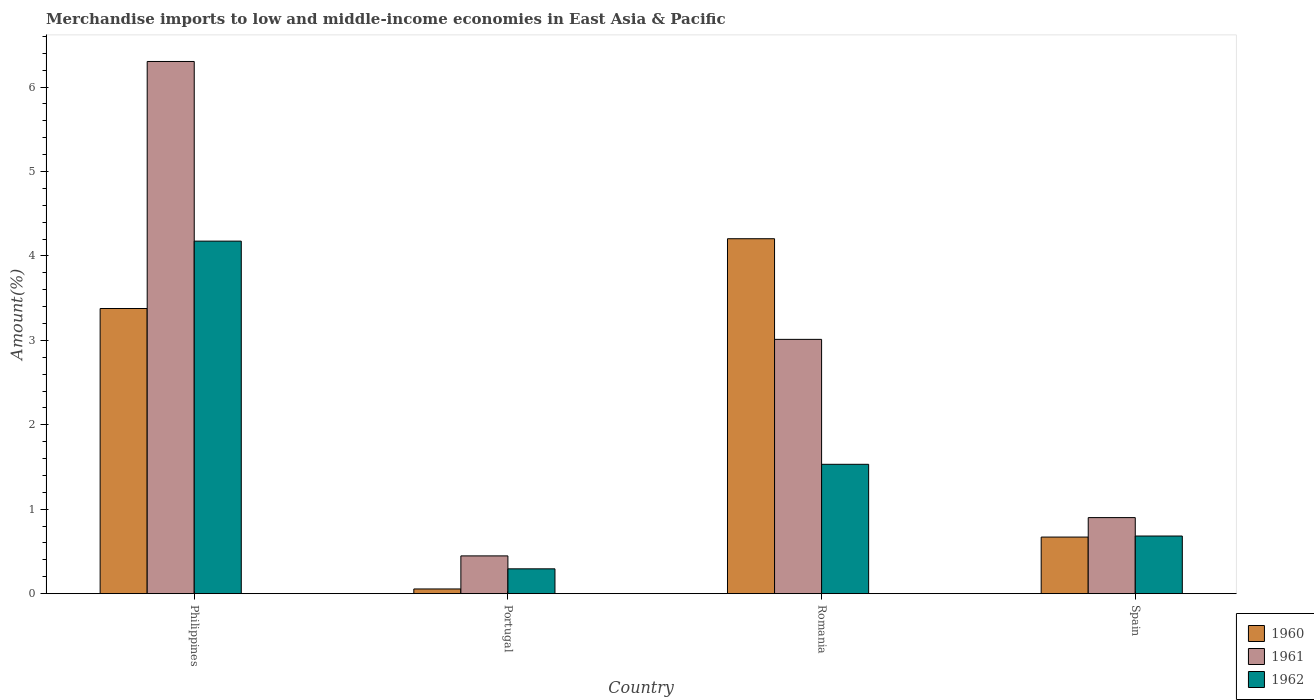How many groups of bars are there?
Give a very brief answer. 4. What is the percentage of amount earned from merchandise imports in 1962 in Portugal?
Your response must be concise. 0.29. Across all countries, what is the maximum percentage of amount earned from merchandise imports in 1961?
Give a very brief answer. 6.3. Across all countries, what is the minimum percentage of amount earned from merchandise imports in 1962?
Keep it short and to the point. 0.29. In which country was the percentage of amount earned from merchandise imports in 1962 maximum?
Offer a terse response. Philippines. What is the total percentage of amount earned from merchandise imports in 1961 in the graph?
Provide a succinct answer. 10.66. What is the difference between the percentage of amount earned from merchandise imports in 1961 in Philippines and that in Portugal?
Your response must be concise. 5.86. What is the difference between the percentage of amount earned from merchandise imports in 1961 in Philippines and the percentage of amount earned from merchandise imports in 1962 in Romania?
Your answer should be very brief. 4.77. What is the average percentage of amount earned from merchandise imports in 1960 per country?
Offer a terse response. 2.08. What is the difference between the percentage of amount earned from merchandise imports of/in 1962 and percentage of amount earned from merchandise imports of/in 1961 in Philippines?
Keep it short and to the point. -2.13. In how many countries, is the percentage of amount earned from merchandise imports in 1961 greater than 6 %?
Make the answer very short. 1. What is the ratio of the percentage of amount earned from merchandise imports in 1962 in Philippines to that in Portugal?
Offer a very short reply. 14.2. Is the difference between the percentage of amount earned from merchandise imports in 1962 in Philippines and Spain greater than the difference between the percentage of amount earned from merchandise imports in 1961 in Philippines and Spain?
Make the answer very short. No. What is the difference between the highest and the second highest percentage of amount earned from merchandise imports in 1960?
Provide a succinct answer. -2.71. What is the difference between the highest and the lowest percentage of amount earned from merchandise imports in 1960?
Give a very brief answer. 4.15. What does the 1st bar from the left in Portugal represents?
Give a very brief answer. 1960. How many countries are there in the graph?
Give a very brief answer. 4. What is the difference between two consecutive major ticks on the Y-axis?
Make the answer very short. 1. Where does the legend appear in the graph?
Keep it short and to the point. Bottom right. How are the legend labels stacked?
Ensure brevity in your answer.  Vertical. What is the title of the graph?
Keep it short and to the point. Merchandise imports to low and middle-income economies in East Asia & Pacific. Does "2004" appear as one of the legend labels in the graph?
Provide a succinct answer. No. What is the label or title of the X-axis?
Give a very brief answer. Country. What is the label or title of the Y-axis?
Make the answer very short. Amount(%). What is the Amount(%) in 1960 in Philippines?
Your response must be concise. 3.38. What is the Amount(%) of 1961 in Philippines?
Offer a very short reply. 6.3. What is the Amount(%) of 1962 in Philippines?
Give a very brief answer. 4.18. What is the Amount(%) in 1960 in Portugal?
Offer a terse response. 0.06. What is the Amount(%) of 1961 in Portugal?
Your answer should be very brief. 0.45. What is the Amount(%) of 1962 in Portugal?
Provide a short and direct response. 0.29. What is the Amount(%) in 1960 in Romania?
Your response must be concise. 4.2. What is the Amount(%) in 1961 in Romania?
Offer a terse response. 3.01. What is the Amount(%) of 1962 in Romania?
Offer a terse response. 1.53. What is the Amount(%) of 1960 in Spain?
Keep it short and to the point. 0.67. What is the Amount(%) in 1961 in Spain?
Make the answer very short. 0.9. What is the Amount(%) of 1962 in Spain?
Provide a succinct answer. 0.68. Across all countries, what is the maximum Amount(%) in 1960?
Your answer should be very brief. 4.2. Across all countries, what is the maximum Amount(%) in 1961?
Make the answer very short. 6.3. Across all countries, what is the maximum Amount(%) of 1962?
Provide a succinct answer. 4.18. Across all countries, what is the minimum Amount(%) of 1960?
Your response must be concise. 0.06. Across all countries, what is the minimum Amount(%) in 1961?
Give a very brief answer. 0.45. Across all countries, what is the minimum Amount(%) of 1962?
Make the answer very short. 0.29. What is the total Amount(%) in 1960 in the graph?
Offer a terse response. 8.31. What is the total Amount(%) of 1961 in the graph?
Keep it short and to the point. 10.66. What is the total Amount(%) of 1962 in the graph?
Your answer should be very brief. 6.68. What is the difference between the Amount(%) of 1960 in Philippines and that in Portugal?
Provide a short and direct response. 3.32. What is the difference between the Amount(%) in 1961 in Philippines and that in Portugal?
Give a very brief answer. 5.86. What is the difference between the Amount(%) of 1962 in Philippines and that in Portugal?
Your response must be concise. 3.88. What is the difference between the Amount(%) in 1960 in Philippines and that in Romania?
Give a very brief answer. -0.83. What is the difference between the Amount(%) in 1961 in Philippines and that in Romania?
Give a very brief answer. 3.29. What is the difference between the Amount(%) of 1962 in Philippines and that in Romania?
Ensure brevity in your answer.  2.64. What is the difference between the Amount(%) in 1960 in Philippines and that in Spain?
Your answer should be very brief. 2.71. What is the difference between the Amount(%) in 1961 in Philippines and that in Spain?
Your answer should be very brief. 5.4. What is the difference between the Amount(%) in 1962 in Philippines and that in Spain?
Keep it short and to the point. 3.49. What is the difference between the Amount(%) in 1960 in Portugal and that in Romania?
Make the answer very short. -4.15. What is the difference between the Amount(%) in 1961 in Portugal and that in Romania?
Your answer should be very brief. -2.56. What is the difference between the Amount(%) in 1962 in Portugal and that in Romania?
Provide a succinct answer. -1.24. What is the difference between the Amount(%) of 1960 in Portugal and that in Spain?
Give a very brief answer. -0.61. What is the difference between the Amount(%) in 1961 in Portugal and that in Spain?
Your answer should be very brief. -0.45. What is the difference between the Amount(%) of 1962 in Portugal and that in Spain?
Your answer should be very brief. -0.39. What is the difference between the Amount(%) of 1960 in Romania and that in Spain?
Offer a very short reply. 3.53. What is the difference between the Amount(%) of 1961 in Romania and that in Spain?
Ensure brevity in your answer.  2.11. What is the difference between the Amount(%) of 1962 in Romania and that in Spain?
Provide a succinct answer. 0.85. What is the difference between the Amount(%) in 1960 in Philippines and the Amount(%) in 1961 in Portugal?
Keep it short and to the point. 2.93. What is the difference between the Amount(%) of 1960 in Philippines and the Amount(%) of 1962 in Portugal?
Give a very brief answer. 3.08. What is the difference between the Amount(%) in 1961 in Philippines and the Amount(%) in 1962 in Portugal?
Provide a short and direct response. 6.01. What is the difference between the Amount(%) in 1960 in Philippines and the Amount(%) in 1961 in Romania?
Provide a short and direct response. 0.37. What is the difference between the Amount(%) in 1960 in Philippines and the Amount(%) in 1962 in Romania?
Provide a succinct answer. 1.85. What is the difference between the Amount(%) of 1961 in Philippines and the Amount(%) of 1962 in Romania?
Offer a very short reply. 4.77. What is the difference between the Amount(%) of 1960 in Philippines and the Amount(%) of 1961 in Spain?
Make the answer very short. 2.48. What is the difference between the Amount(%) of 1960 in Philippines and the Amount(%) of 1962 in Spain?
Make the answer very short. 2.69. What is the difference between the Amount(%) of 1961 in Philippines and the Amount(%) of 1962 in Spain?
Provide a short and direct response. 5.62. What is the difference between the Amount(%) in 1960 in Portugal and the Amount(%) in 1961 in Romania?
Ensure brevity in your answer.  -2.96. What is the difference between the Amount(%) in 1960 in Portugal and the Amount(%) in 1962 in Romania?
Keep it short and to the point. -1.48. What is the difference between the Amount(%) of 1961 in Portugal and the Amount(%) of 1962 in Romania?
Make the answer very short. -1.08. What is the difference between the Amount(%) of 1960 in Portugal and the Amount(%) of 1961 in Spain?
Provide a short and direct response. -0.85. What is the difference between the Amount(%) in 1960 in Portugal and the Amount(%) in 1962 in Spain?
Give a very brief answer. -0.63. What is the difference between the Amount(%) in 1961 in Portugal and the Amount(%) in 1962 in Spain?
Offer a very short reply. -0.24. What is the difference between the Amount(%) of 1960 in Romania and the Amount(%) of 1961 in Spain?
Provide a succinct answer. 3.3. What is the difference between the Amount(%) of 1960 in Romania and the Amount(%) of 1962 in Spain?
Provide a succinct answer. 3.52. What is the difference between the Amount(%) of 1961 in Romania and the Amount(%) of 1962 in Spain?
Ensure brevity in your answer.  2.33. What is the average Amount(%) of 1960 per country?
Your answer should be very brief. 2.08. What is the average Amount(%) in 1961 per country?
Provide a succinct answer. 2.67. What is the average Amount(%) in 1962 per country?
Your answer should be very brief. 1.67. What is the difference between the Amount(%) in 1960 and Amount(%) in 1961 in Philippines?
Keep it short and to the point. -2.93. What is the difference between the Amount(%) in 1960 and Amount(%) in 1962 in Philippines?
Give a very brief answer. -0.8. What is the difference between the Amount(%) in 1961 and Amount(%) in 1962 in Philippines?
Ensure brevity in your answer.  2.13. What is the difference between the Amount(%) of 1960 and Amount(%) of 1961 in Portugal?
Ensure brevity in your answer.  -0.39. What is the difference between the Amount(%) of 1960 and Amount(%) of 1962 in Portugal?
Provide a succinct answer. -0.24. What is the difference between the Amount(%) of 1961 and Amount(%) of 1962 in Portugal?
Offer a very short reply. 0.15. What is the difference between the Amount(%) in 1960 and Amount(%) in 1961 in Romania?
Offer a terse response. 1.19. What is the difference between the Amount(%) of 1960 and Amount(%) of 1962 in Romania?
Provide a succinct answer. 2.67. What is the difference between the Amount(%) of 1961 and Amount(%) of 1962 in Romania?
Offer a very short reply. 1.48. What is the difference between the Amount(%) in 1960 and Amount(%) in 1961 in Spain?
Make the answer very short. -0.23. What is the difference between the Amount(%) in 1960 and Amount(%) in 1962 in Spain?
Ensure brevity in your answer.  -0.01. What is the difference between the Amount(%) in 1961 and Amount(%) in 1962 in Spain?
Make the answer very short. 0.22. What is the ratio of the Amount(%) in 1960 in Philippines to that in Portugal?
Provide a short and direct response. 60.74. What is the ratio of the Amount(%) of 1961 in Philippines to that in Portugal?
Keep it short and to the point. 14.09. What is the ratio of the Amount(%) in 1962 in Philippines to that in Portugal?
Offer a very short reply. 14.2. What is the ratio of the Amount(%) of 1960 in Philippines to that in Romania?
Keep it short and to the point. 0.8. What is the ratio of the Amount(%) in 1961 in Philippines to that in Romania?
Your answer should be compact. 2.09. What is the ratio of the Amount(%) in 1962 in Philippines to that in Romania?
Offer a terse response. 2.73. What is the ratio of the Amount(%) of 1960 in Philippines to that in Spain?
Make the answer very short. 5.04. What is the ratio of the Amount(%) in 1961 in Philippines to that in Spain?
Offer a terse response. 7. What is the ratio of the Amount(%) of 1962 in Philippines to that in Spain?
Keep it short and to the point. 6.12. What is the ratio of the Amount(%) of 1960 in Portugal to that in Romania?
Your response must be concise. 0.01. What is the ratio of the Amount(%) in 1961 in Portugal to that in Romania?
Make the answer very short. 0.15. What is the ratio of the Amount(%) of 1962 in Portugal to that in Romania?
Offer a terse response. 0.19. What is the ratio of the Amount(%) of 1960 in Portugal to that in Spain?
Offer a terse response. 0.08. What is the ratio of the Amount(%) of 1961 in Portugal to that in Spain?
Provide a short and direct response. 0.5. What is the ratio of the Amount(%) in 1962 in Portugal to that in Spain?
Offer a very short reply. 0.43. What is the ratio of the Amount(%) in 1960 in Romania to that in Spain?
Your response must be concise. 6.27. What is the ratio of the Amount(%) in 1961 in Romania to that in Spain?
Your answer should be compact. 3.34. What is the ratio of the Amount(%) in 1962 in Romania to that in Spain?
Offer a very short reply. 2.24. What is the difference between the highest and the second highest Amount(%) in 1960?
Offer a very short reply. 0.83. What is the difference between the highest and the second highest Amount(%) of 1961?
Offer a very short reply. 3.29. What is the difference between the highest and the second highest Amount(%) in 1962?
Offer a very short reply. 2.64. What is the difference between the highest and the lowest Amount(%) in 1960?
Offer a terse response. 4.15. What is the difference between the highest and the lowest Amount(%) in 1961?
Make the answer very short. 5.86. What is the difference between the highest and the lowest Amount(%) in 1962?
Your answer should be compact. 3.88. 